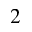Convert formula to latex. <formula><loc_0><loc_0><loc_500><loc_500>^ { 2 }</formula> 